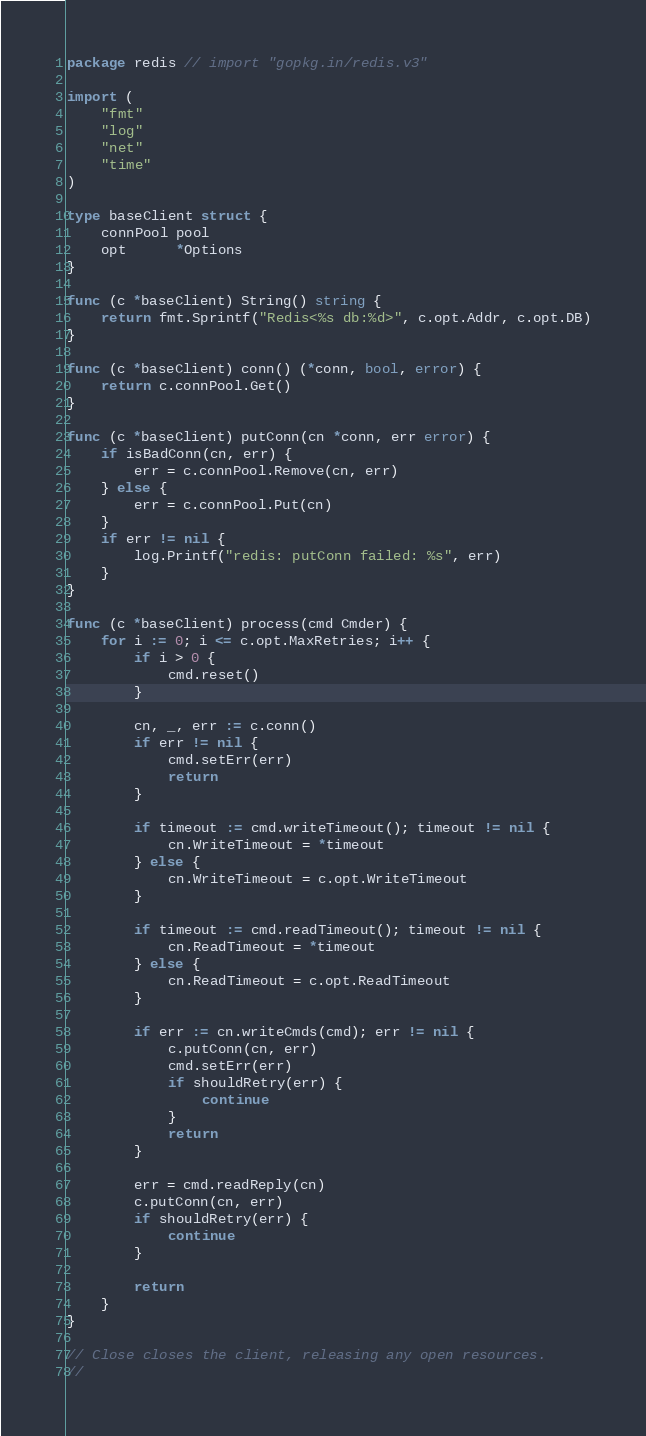Convert code to text. <code><loc_0><loc_0><loc_500><loc_500><_Go_>package redis // import "gopkg.in/redis.v3"

import (
	"fmt"
	"log"
	"net"
	"time"
)

type baseClient struct {
	connPool pool
	opt      *Options
}

func (c *baseClient) String() string {
	return fmt.Sprintf("Redis<%s db:%d>", c.opt.Addr, c.opt.DB)
}

func (c *baseClient) conn() (*conn, bool, error) {
	return c.connPool.Get()
}

func (c *baseClient) putConn(cn *conn, err error) {
	if isBadConn(cn, err) {
		err = c.connPool.Remove(cn, err)
	} else {
		err = c.connPool.Put(cn)
	}
	if err != nil {
		log.Printf("redis: putConn failed: %s", err)
	}
}

func (c *baseClient) process(cmd Cmder) {
	for i := 0; i <= c.opt.MaxRetries; i++ {
		if i > 0 {
			cmd.reset()
		}

		cn, _, err := c.conn()
		if err != nil {
			cmd.setErr(err)
			return
		}

		if timeout := cmd.writeTimeout(); timeout != nil {
			cn.WriteTimeout = *timeout
		} else {
			cn.WriteTimeout = c.opt.WriteTimeout
		}

		if timeout := cmd.readTimeout(); timeout != nil {
			cn.ReadTimeout = *timeout
		} else {
			cn.ReadTimeout = c.opt.ReadTimeout
		}

		if err := cn.writeCmds(cmd); err != nil {
			c.putConn(cn, err)
			cmd.setErr(err)
			if shouldRetry(err) {
				continue
			}
			return
		}

		err = cmd.readReply(cn)
		c.putConn(cn, err)
		if shouldRetry(err) {
			continue
		}

		return
	}
}

// Close closes the client, releasing any open resources.
//</code> 